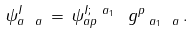Convert formula to latex. <formula><loc_0><loc_0><loc_500><loc_500>\psi ^ { I } _ { a \ a } \, = \, \psi ^ { I ; \ a _ { 1 } } _ { a p } \, \ g ^ { p } _ { \ a _ { 1 } \ a } \, .</formula> 